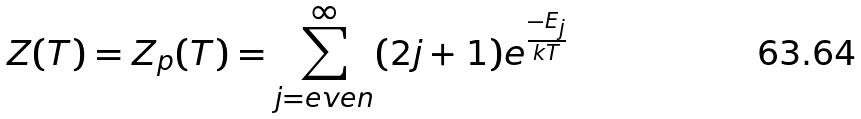<formula> <loc_0><loc_0><loc_500><loc_500>Z ( T ) = Z _ { p } ( T ) = \sum _ { j = e v e n } ^ { \infty } ( 2 j + 1 ) e ^ { \frac { - E _ { j } } { k T } }</formula> 